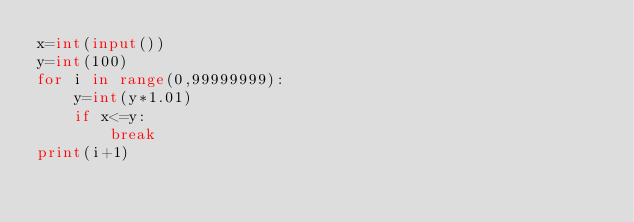Convert code to text. <code><loc_0><loc_0><loc_500><loc_500><_Python_>x=int(input())
y=int(100)
for i in range(0,99999999):
    y=int(y*1.01)
    if x<=y:
        break
print(i+1)</code> 